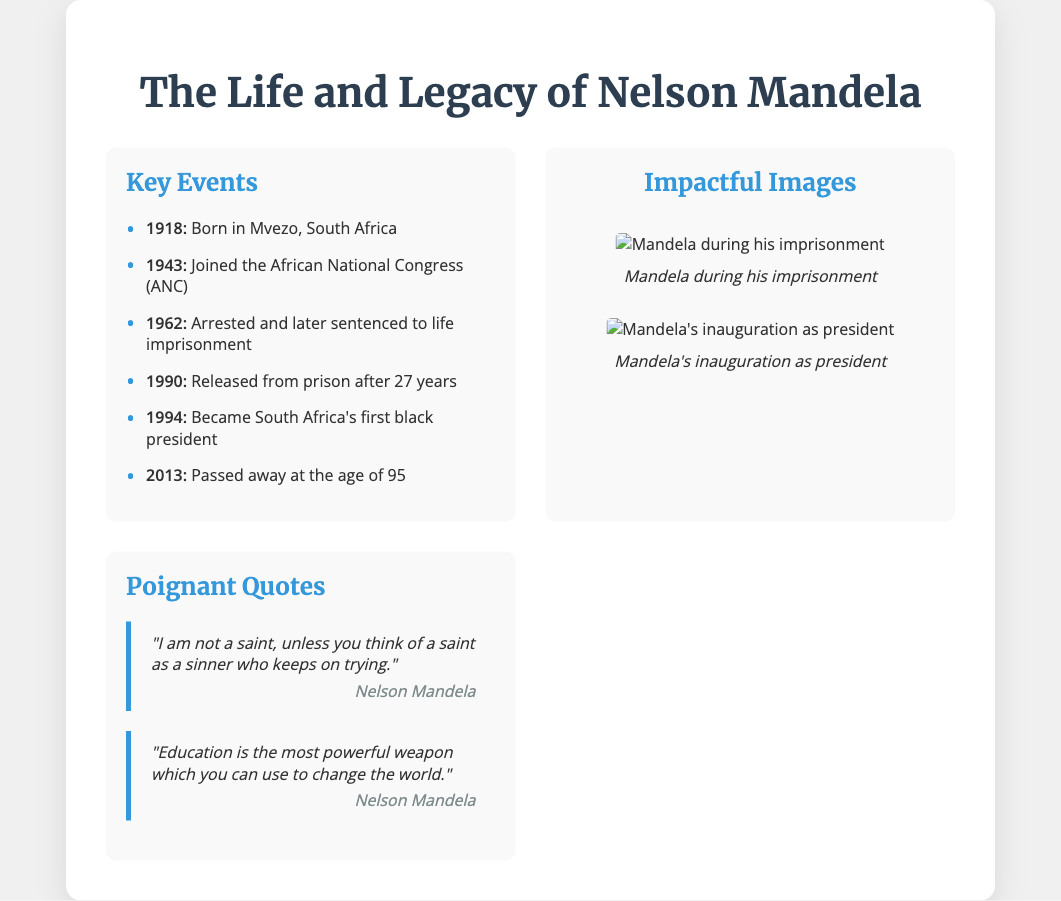What year was Nelson Mandela born? The document provides the year of Mandela's birth, which is stated in the timeline as 1918.
Answer: 1918 How many years did Mandela spend in prison? The timeline mentions he was imprisoned in 1962 and released in 1990, so the calculation is 1990 - 1962 = 28 years.
Answer: 28 years What organization did Mandela join in 1943? The timeline indicates that he joined the African National Congress (ANC) in the year 1943.
Answer: African National Congress (ANC) What significant milestone occurred in 1994? The timeline notes that Mandela became South Africa's first black president in 1994.
Answer: First black president What is one of Mandela's quotes mentioned in the document? The quotes section presents a notable quote from Mandela about education being a powerful weapon to change the world.
Answer: "Education is the most powerful weapon which you can use to change the world." How old was Mandela when he passed away? According to the timeline, Mandela passed away in 2013 at the age of 95.
Answer: 95 Which image depicts Mandela during his imprisonment? The images section describes a photo of Mandela in prison, specified as "Mandela during his imprisonment".
Answer: Mandela during his imprisonment What is the color used for the timeline bullet points? The styling in the document states that the bullet points for the timeline are colored in a shade of blue, specifically #3498db.
Answer: Blue What is the primary theme of the presentation slide? The title of the presentation clearly outlines that the main focus is on Nelson Mandela's life and legacy.
Answer: Nelson Mandela's life and legacy 